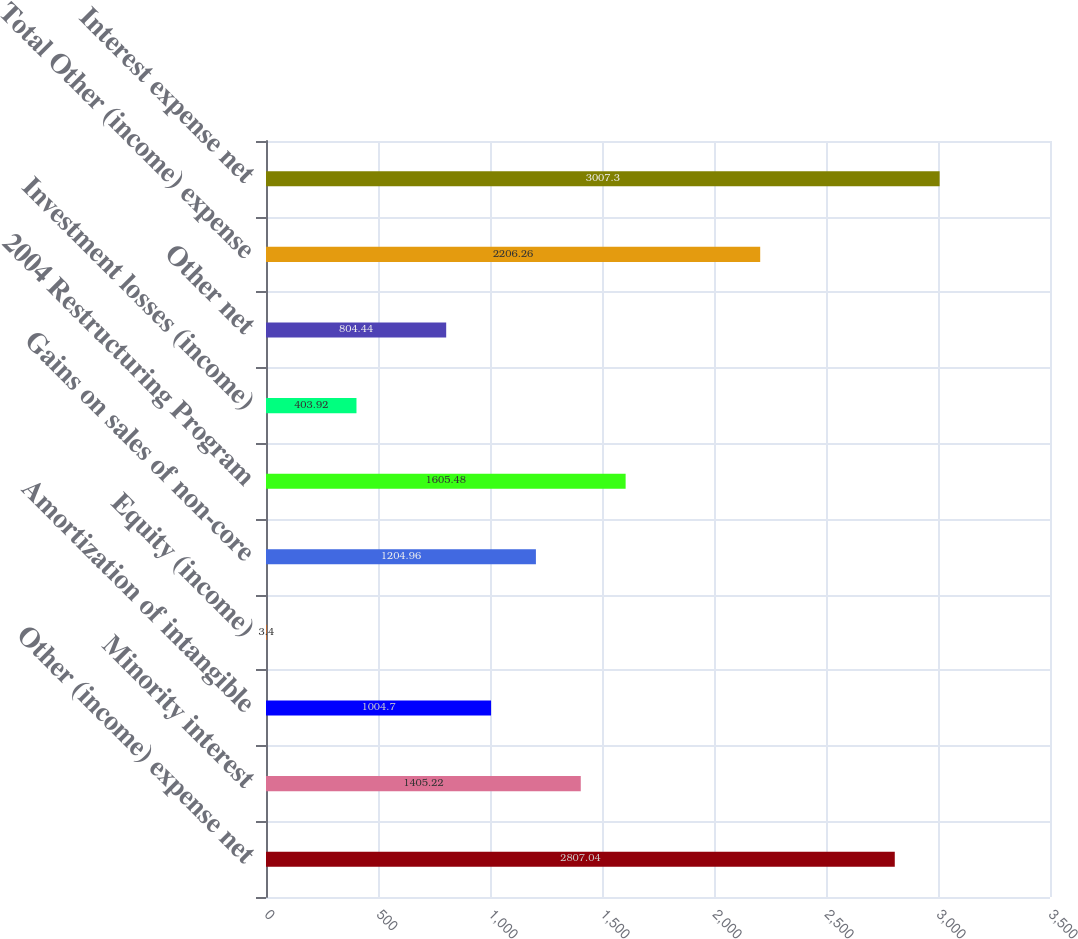Convert chart. <chart><loc_0><loc_0><loc_500><loc_500><bar_chart><fcel>Other (income) expense net<fcel>Minority interest<fcel>Amortization of intangible<fcel>Equity (income)<fcel>Gains on sales of non-core<fcel>2004 Restructuring Program<fcel>Investment losses (income)<fcel>Other net<fcel>Total Other (income) expense<fcel>Interest expense net<nl><fcel>2807.04<fcel>1405.22<fcel>1004.7<fcel>3.4<fcel>1204.96<fcel>1605.48<fcel>403.92<fcel>804.44<fcel>2206.26<fcel>3007.3<nl></chart> 